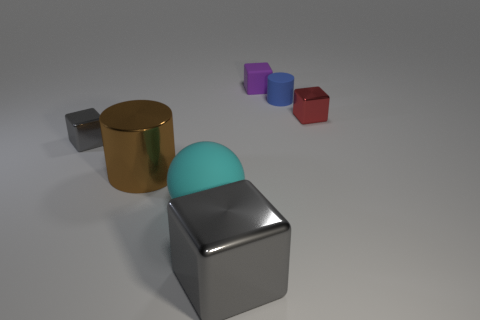Subtract all gray cylinders. Subtract all cyan balls. How many cylinders are left? 2 Add 1 large gray cubes. How many objects exist? 8 Subtract all cubes. How many objects are left? 3 Subtract all big things. Subtract all cyan matte objects. How many objects are left? 3 Add 5 big brown metal cylinders. How many big brown metal cylinders are left? 6 Add 2 cylinders. How many cylinders exist? 4 Subtract 1 purple blocks. How many objects are left? 6 